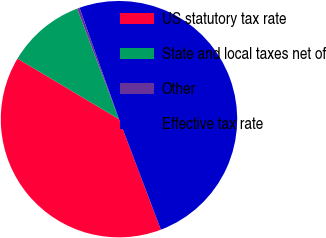<chart> <loc_0><loc_0><loc_500><loc_500><pie_chart><fcel>US statutory tax rate<fcel>State and local taxes net of<fcel>Other<fcel>Effective tax rate<nl><fcel>39.33%<fcel>10.67%<fcel>0.34%<fcel>49.66%<nl></chart> 